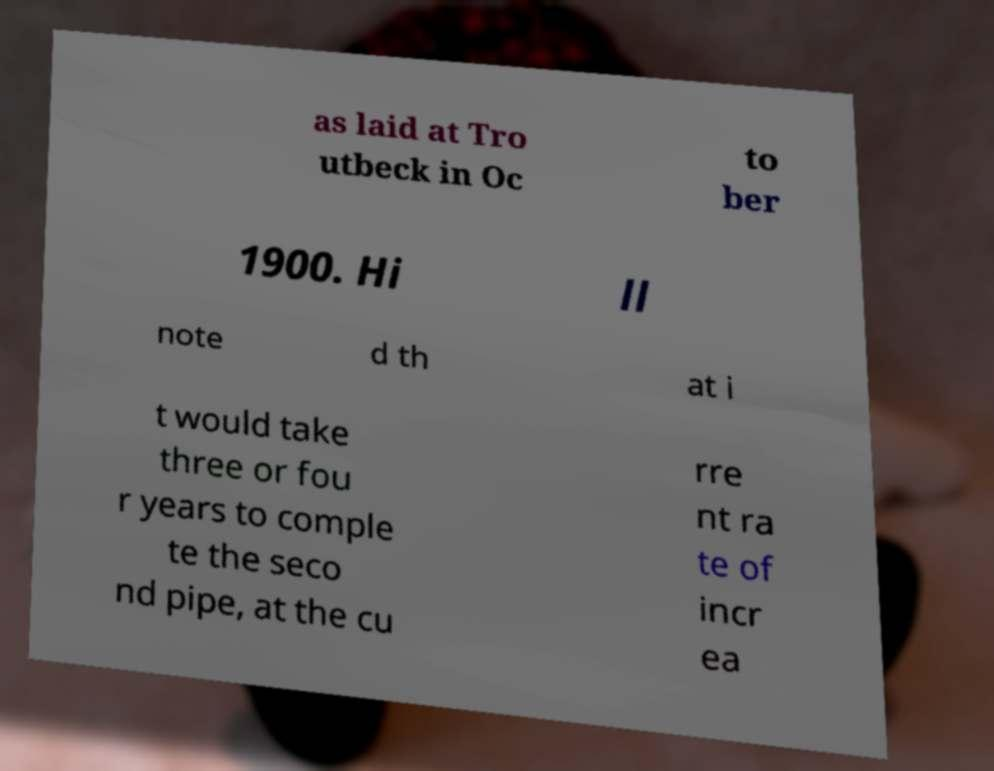Can you read and provide the text displayed in the image?This photo seems to have some interesting text. Can you extract and type it out for me? as laid at Tro utbeck in Oc to ber 1900. Hi ll note d th at i t would take three or fou r years to comple te the seco nd pipe, at the cu rre nt ra te of incr ea 